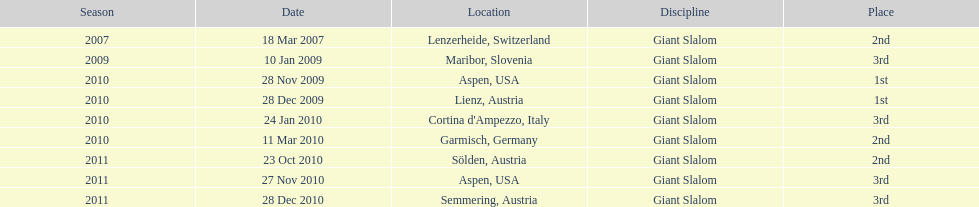At which location did she secure her initial win? Aspen, USA. 